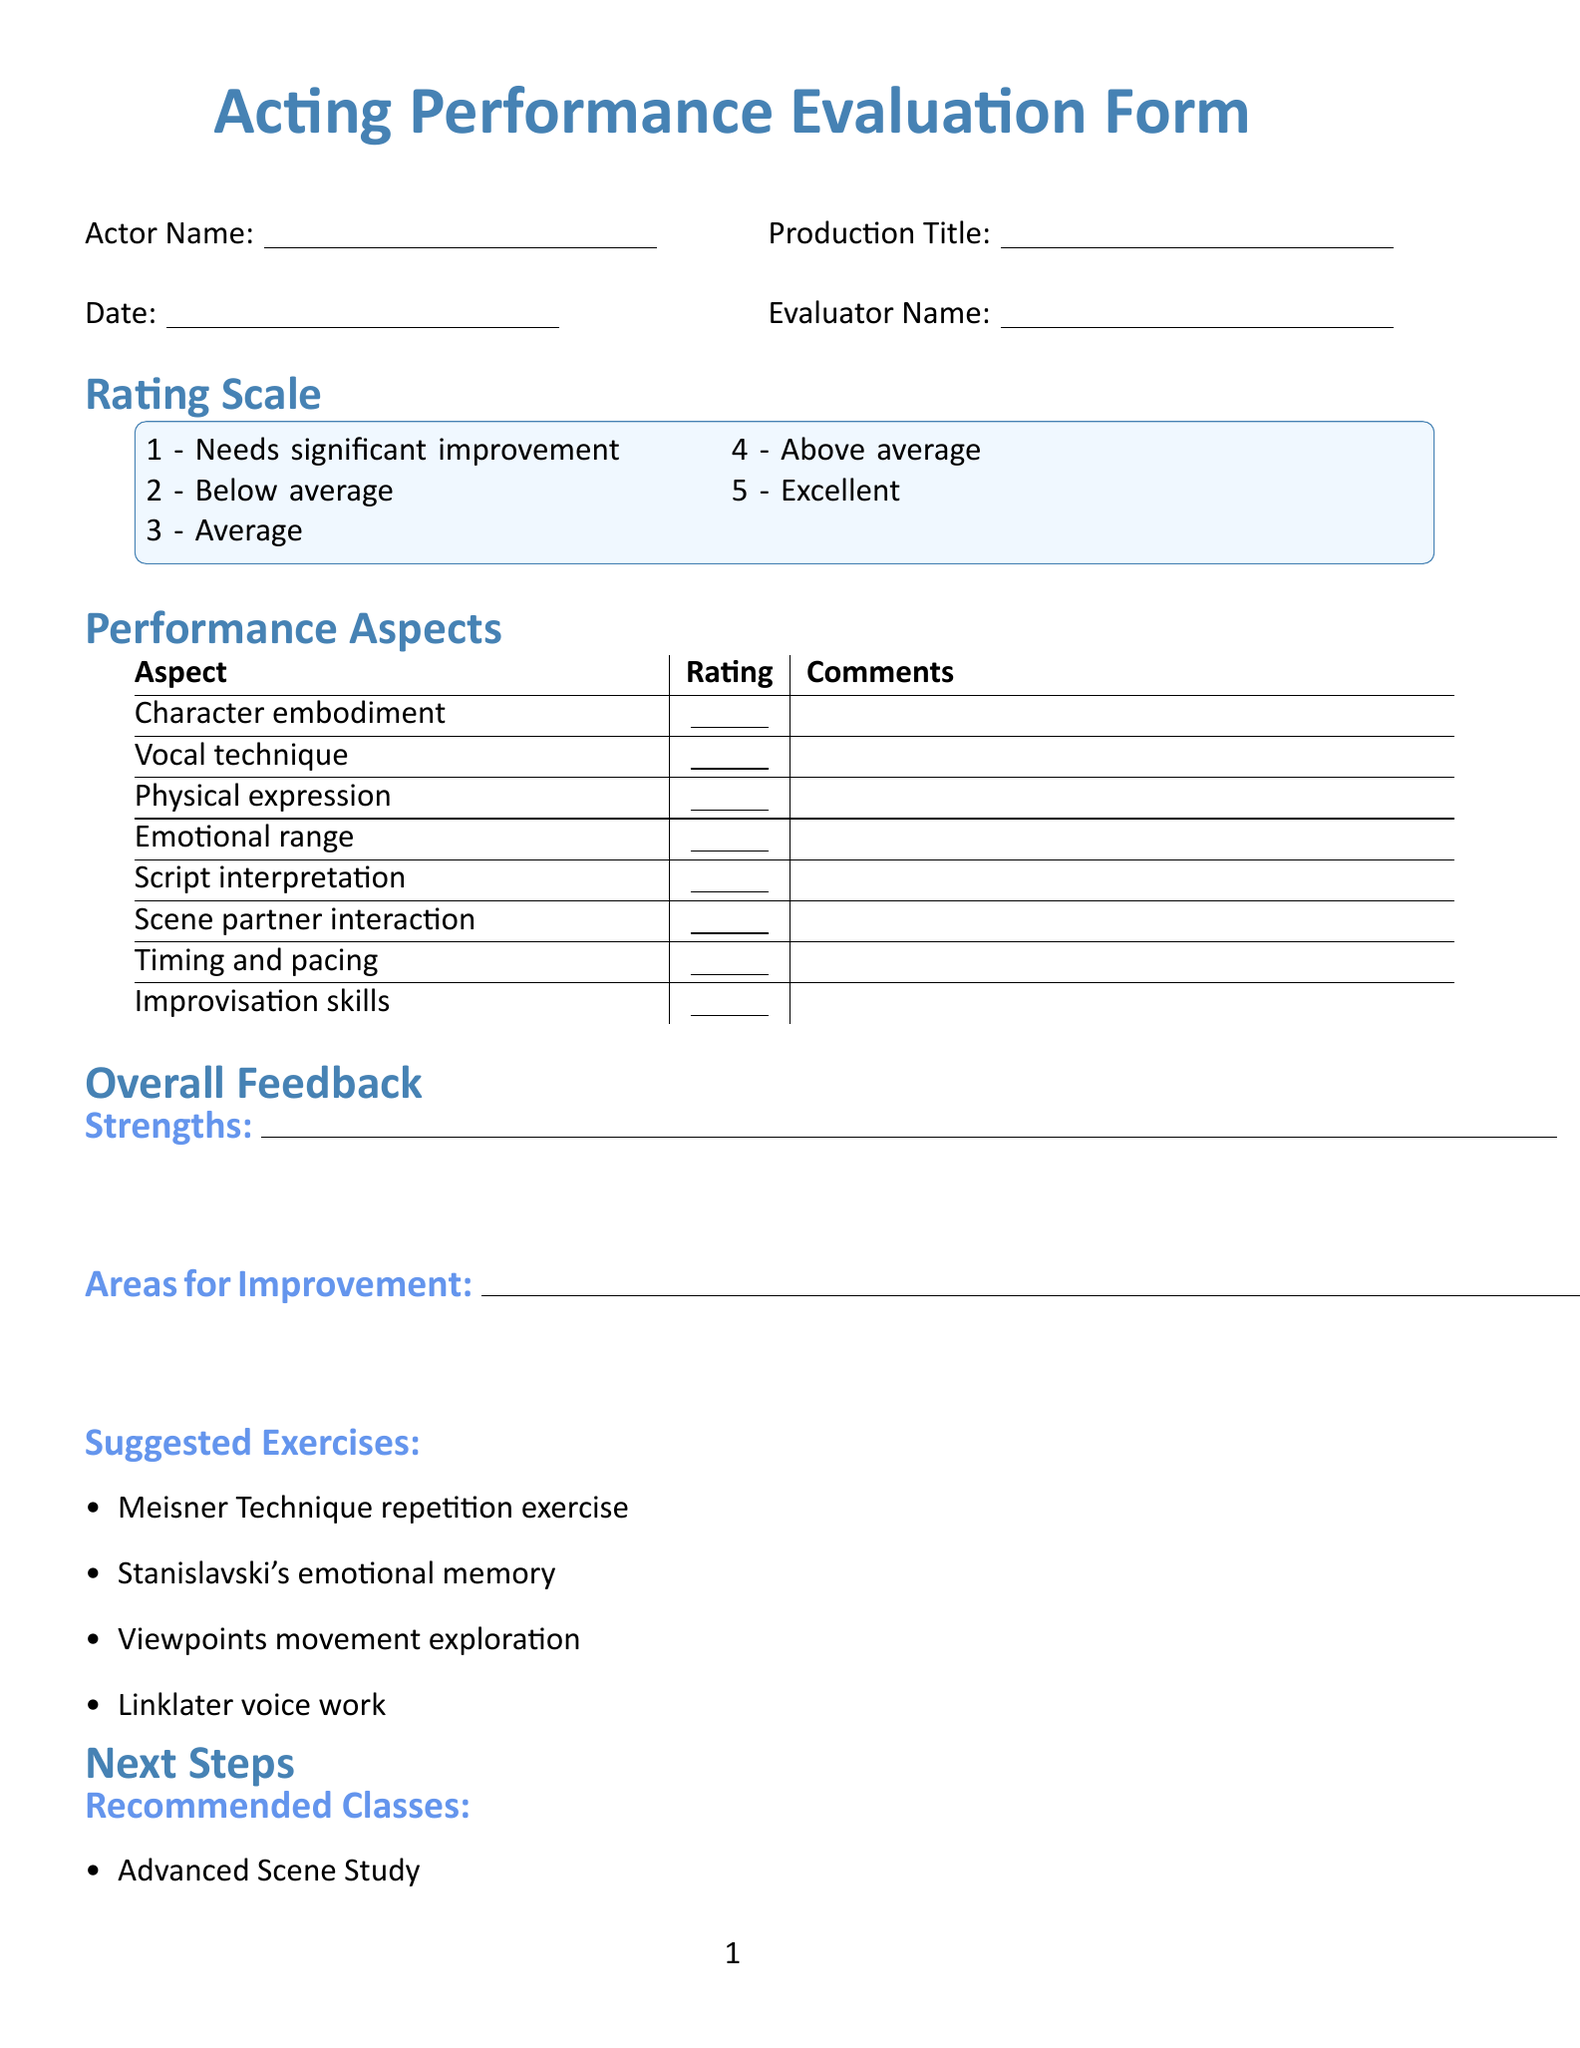What is the title of the form? The title of the form is presented at the top of the document in a large font.
Answer: Acting Performance Evaluation Form Who is the author of "An Actor Prepares"? The document lists references for additional resources, including authors of books and courses.
Answer: Constantin Stanislavski How many performance aspects are evaluated? The document outlines specific aspects that are evaluated in a tabular format.
Answer: Eight What is the maximum rating on the scale? The rating scale is provided with descriptions of each rating, ranging from 1 to 5.
Answer: Five What type of exercises are suggested in the overall feedback section? The document includes recommended exercises under the overall feedback section to aid improvement.
Answer: Meisner Technique repetition exercise What is a recommended class listed for next steps? The next steps section includes various classes that are recommended for actors.
Answer: Advanced Scene Study What is the signature line for the actor? The document includes signature lines for both the actor and the coach at the bottom.
Answer: Actor Signature What is the date designation in the form? The document includes a specific field for recording the date of the evaluation.
Answer: Date: How many resources are listed under additional resources? The additional resources section provides various types of learning materials related to acting.
Answer: Three 